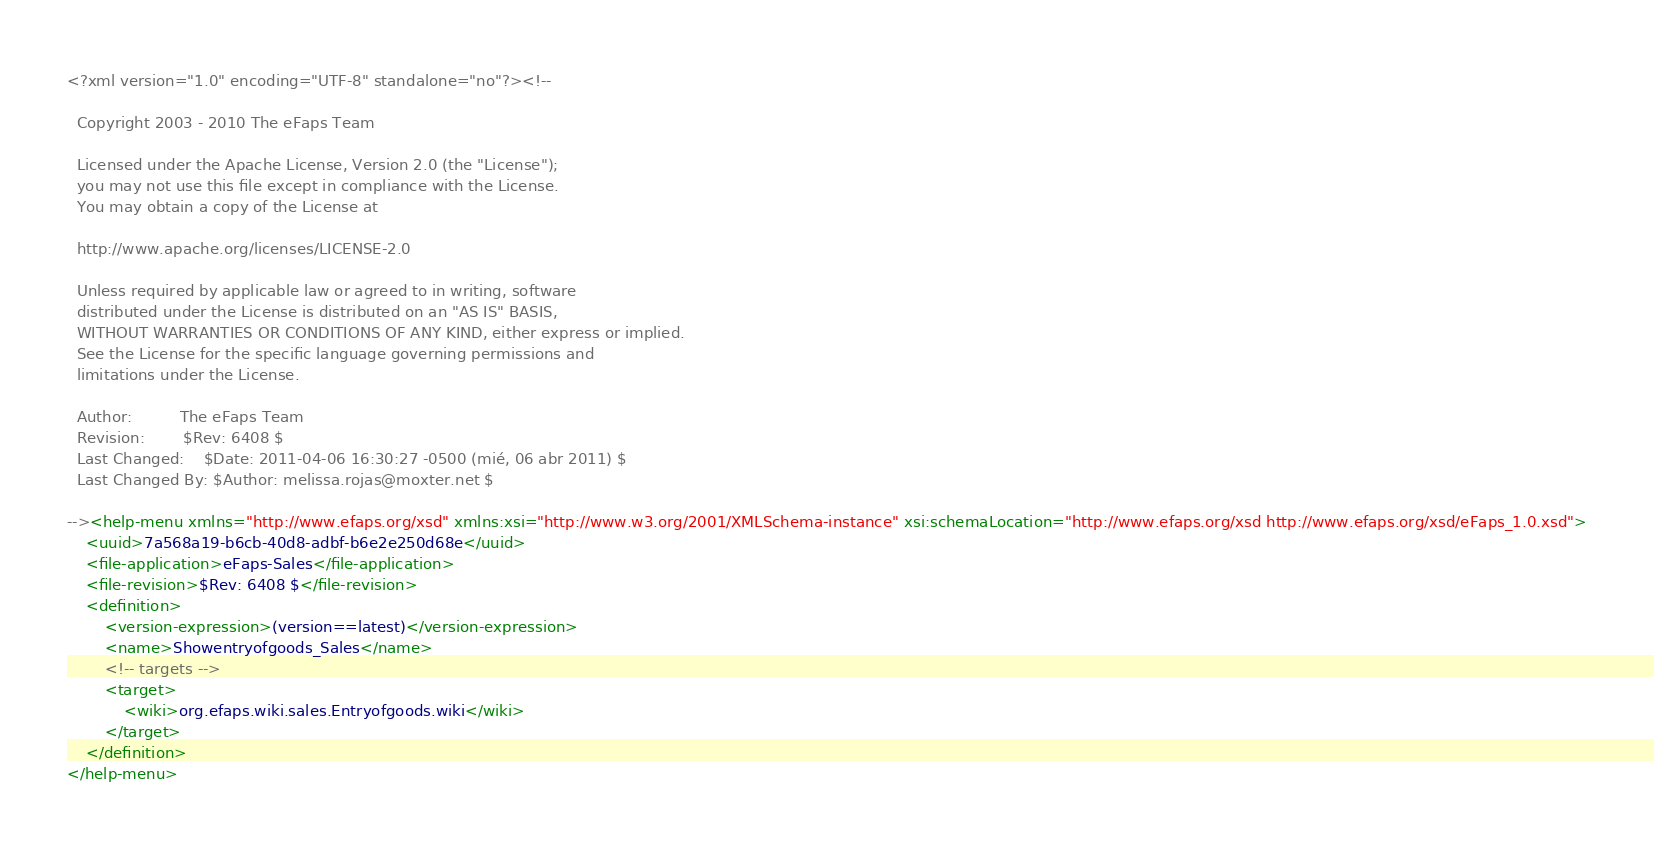<code> <loc_0><loc_0><loc_500><loc_500><_XML_><?xml version="1.0" encoding="UTF-8" standalone="no"?><!--

  Copyright 2003 - 2010 The eFaps Team

  Licensed under the Apache License, Version 2.0 (the "License");
  you may not use this file except in compliance with the License.
  You may obtain a copy of the License at

  http://www.apache.org/licenses/LICENSE-2.0

  Unless required by applicable law or agreed to in writing, software
  distributed under the License is distributed on an "AS IS" BASIS,
  WITHOUT WARRANTIES OR CONDITIONS OF ANY KIND, either express or implied.
  See the License for the specific language governing permissions and
  limitations under the License.

  Author:          The eFaps Team
  Revision:        $Rev: 6408 $
  Last Changed:    $Date: 2011-04-06 16:30:27 -0500 (mié, 06 abr 2011) $
  Last Changed By: $Author: melissa.rojas@moxter.net $

--><help-menu xmlns="http://www.efaps.org/xsd" xmlns:xsi="http://www.w3.org/2001/XMLSchema-instance" xsi:schemaLocation="http://www.efaps.org/xsd http://www.efaps.org/xsd/eFaps_1.0.xsd">
    <uuid>7a568a19-b6cb-40d8-adbf-b6e2e250d68e</uuid>
    <file-application>eFaps-Sales</file-application>
    <file-revision>$Rev: 6408 $</file-revision>
    <definition>
        <version-expression>(version==latest)</version-expression>
        <name>Showentryofgoods_Sales</name>
        <!-- targets -->
        <target>
            <wiki>org.efaps.wiki.sales.Entryofgoods.wiki</wiki>
        </target>
    </definition>
</help-menu></code> 